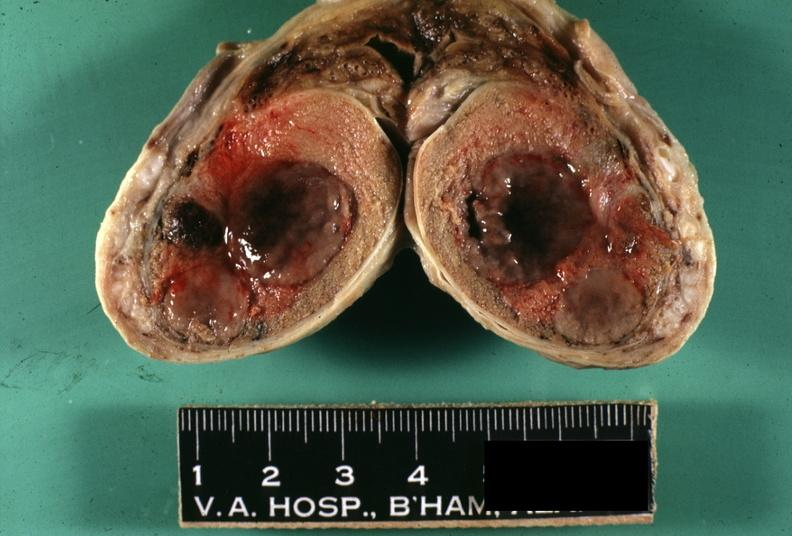what is present?
Answer the question using a single word or phrase. Metastatic melanoma 